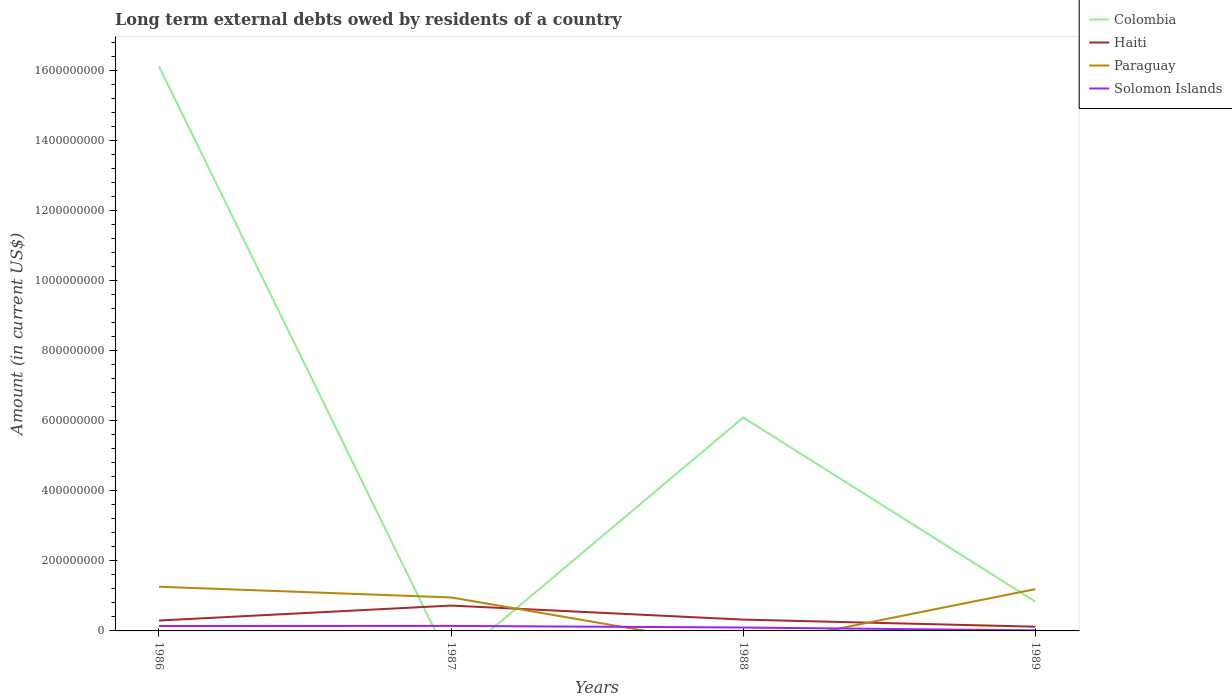How many different coloured lines are there?
Your answer should be compact. 4. Is the number of lines equal to the number of legend labels?
Offer a terse response. No. What is the total amount of long-term external debts owed by residents in Haiti in the graph?
Your answer should be compact. 1.77e+07. What is the difference between the highest and the second highest amount of long-term external debts owed by residents in Colombia?
Ensure brevity in your answer.  1.61e+09. How many lines are there?
Give a very brief answer. 4. What is the difference between two consecutive major ticks on the Y-axis?
Your response must be concise. 2.00e+08. Does the graph contain any zero values?
Make the answer very short. Yes. Does the graph contain grids?
Ensure brevity in your answer.  No. How many legend labels are there?
Your answer should be compact. 4. How are the legend labels stacked?
Make the answer very short. Vertical. What is the title of the graph?
Offer a terse response. Long term external debts owed by residents of a country. Does "Iceland" appear as one of the legend labels in the graph?
Provide a succinct answer. No. What is the label or title of the X-axis?
Your answer should be compact. Years. What is the label or title of the Y-axis?
Give a very brief answer. Amount (in current US$). What is the Amount (in current US$) of Colombia in 1986?
Ensure brevity in your answer.  1.61e+09. What is the Amount (in current US$) of Haiti in 1986?
Provide a succinct answer. 2.97e+07. What is the Amount (in current US$) of Paraguay in 1986?
Offer a very short reply. 1.26e+08. What is the Amount (in current US$) of Solomon Islands in 1986?
Your answer should be very brief. 1.40e+07. What is the Amount (in current US$) in Colombia in 1987?
Offer a very short reply. 0. What is the Amount (in current US$) of Haiti in 1987?
Make the answer very short. 7.24e+07. What is the Amount (in current US$) of Paraguay in 1987?
Offer a very short reply. 9.57e+07. What is the Amount (in current US$) of Solomon Islands in 1987?
Keep it short and to the point. 1.43e+07. What is the Amount (in current US$) of Colombia in 1988?
Make the answer very short. 6.09e+08. What is the Amount (in current US$) of Haiti in 1988?
Provide a succinct answer. 3.23e+07. What is the Amount (in current US$) in Solomon Islands in 1988?
Offer a very short reply. 9.66e+06. What is the Amount (in current US$) of Colombia in 1989?
Your response must be concise. 8.36e+07. What is the Amount (in current US$) in Haiti in 1989?
Provide a short and direct response. 1.21e+07. What is the Amount (in current US$) of Paraguay in 1989?
Offer a very short reply. 1.19e+08. What is the Amount (in current US$) in Solomon Islands in 1989?
Offer a terse response. 1.51e+06. Across all years, what is the maximum Amount (in current US$) in Colombia?
Offer a terse response. 1.61e+09. Across all years, what is the maximum Amount (in current US$) of Haiti?
Provide a succinct answer. 7.24e+07. Across all years, what is the maximum Amount (in current US$) of Paraguay?
Ensure brevity in your answer.  1.26e+08. Across all years, what is the maximum Amount (in current US$) of Solomon Islands?
Keep it short and to the point. 1.43e+07. Across all years, what is the minimum Amount (in current US$) of Colombia?
Keep it short and to the point. 0. Across all years, what is the minimum Amount (in current US$) in Haiti?
Your answer should be compact. 1.21e+07. Across all years, what is the minimum Amount (in current US$) in Paraguay?
Your response must be concise. 0. Across all years, what is the minimum Amount (in current US$) of Solomon Islands?
Make the answer very short. 1.51e+06. What is the total Amount (in current US$) in Colombia in the graph?
Ensure brevity in your answer.  2.30e+09. What is the total Amount (in current US$) in Haiti in the graph?
Your response must be concise. 1.46e+08. What is the total Amount (in current US$) of Paraguay in the graph?
Keep it short and to the point. 3.41e+08. What is the total Amount (in current US$) in Solomon Islands in the graph?
Your answer should be compact. 3.95e+07. What is the difference between the Amount (in current US$) of Haiti in 1986 and that in 1987?
Your answer should be compact. -4.27e+07. What is the difference between the Amount (in current US$) of Paraguay in 1986 and that in 1987?
Offer a very short reply. 3.05e+07. What is the difference between the Amount (in current US$) of Solomon Islands in 1986 and that in 1987?
Provide a succinct answer. -3.19e+05. What is the difference between the Amount (in current US$) in Colombia in 1986 and that in 1988?
Provide a short and direct response. 1.00e+09. What is the difference between the Amount (in current US$) in Haiti in 1986 and that in 1988?
Ensure brevity in your answer.  -2.56e+06. What is the difference between the Amount (in current US$) in Solomon Islands in 1986 and that in 1988?
Provide a succinct answer. 4.36e+06. What is the difference between the Amount (in current US$) of Colombia in 1986 and that in 1989?
Make the answer very short. 1.53e+09. What is the difference between the Amount (in current US$) in Haiti in 1986 and that in 1989?
Provide a short and direct response. 1.77e+07. What is the difference between the Amount (in current US$) in Paraguay in 1986 and that in 1989?
Offer a terse response. 6.81e+06. What is the difference between the Amount (in current US$) in Solomon Islands in 1986 and that in 1989?
Your answer should be compact. 1.25e+07. What is the difference between the Amount (in current US$) of Haiti in 1987 and that in 1988?
Your answer should be compact. 4.01e+07. What is the difference between the Amount (in current US$) of Solomon Islands in 1987 and that in 1988?
Your answer should be very brief. 4.68e+06. What is the difference between the Amount (in current US$) of Haiti in 1987 and that in 1989?
Your response must be concise. 6.03e+07. What is the difference between the Amount (in current US$) of Paraguay in 1987 and that in 1989?
Offer a terse response. -2.36e+07. What is the difference between the Amount (in current US$) in Solomon Islands in 1987 and that in 1989?
Keep it short and to the point. 1.28e+07. What is the difference between the Amount (in current US$) in Colombia in 1988 and that in 1989?
Provide a succinct answer. 5.26e+08. What is the difference between the Amount (in current US$) of Haiti in 1988 and that in 1989?
Ensure brevity in your answer.  2.02e+07. What is the difference between the Amount (in current US$) of Solomon Islands in 1988 and that in 1989?
Give a very brief answer. 8.15e+06. What is the difference between the Amount (in current US$) in Colombia in 1986 and the Amount (in current US$) in Haiti in 1987?
Provide a short and direct response. 1.54e+09. What is the difference between the Amount (in current US$) of Colombia in 1986 and the Amount (in current US$) of Paraguay in 1987?
Your response must be concise. 1.52e+09. What is the difference between the Amount (in current US$) of Colombia in 1986 and the Amount (in current US$) of Solomon Islands in 1987?
Give a very brief answer. 1.60e+09. What is the difference between the Amount (in current US$) of Haiti in 1986 and the Amount (in current US$) of Paraguay in 1987?
Your answer should be compact. -6.59e+07. What is the difference between the Amount (in current US$) of Haiti in 1986 and the Amount (in current US$) of Solomon Islands in 1987?
Make the answer very short. 1.54e+07. What is the difference between the Amount (in current US$) in Paraguay in 1986 and the Amount (in current US$) in Solomon Islands in 1987?
Your answer should be compact. 1.12e+08. What is the difference between the Amount (in current US$) in Colombia in 1986 and the Amount (in current US$) in Haiti in 1988?
Provide a short and direct response. 1.58e+09. What is the difference between the Amount (in current US$) in Colombia in 1986 and the Amount (in current US$) in Solomon Islands in 1988?
Provide a short and direct response. 1.60e+09. What is the difference between the Amount (in current US$) of Haiti in 1986 and the Amount (in current US$) of Solomon Islands in 1988?
Your answer should be compact. 2.01e+07. What is the difference between the Amount (in current US$) in Paraguay in 1986 and the Amount (in current US$) in Solomon Islands in 1988?
Your answer should be compact. 1.16e+08. What is the difference between the Amount (in current US$) in Colombia in 1986 and the Amount (in current US$) in Haiti in 1989?
Keep it short and to the point. 1.60e+09. What is the difference between the Amount (in current US$) in Colombia in 1986 and the Amount (in current US$) in Paraguay in 1989?
Ensure brevity in your answer.  1.49e+09. What is the difference between the Amount (in current US$) in Colombia in 1986 and the Amount (in current US$) in Solomon Islands in 1989?
Keep it short and to the point. 1.61e+09. What is the difference between the Amount (in current US$) in Haiti in 1986 and the Amount (in current US$) in Paraguay in 1989?
Keep it short and to the point. -8.96e+07. What is the difference between the Amount (in current US$) in Haiti in 1986 and the Amount (in current US$) in Solomon Islands in 1989?
Give a very brief answer. 2.82e+07. What is the difference between the Amount (in current US$) of Paraguay in 1986 and the Amount (in current US$) of Solomon Islands in 1989?
Offer a very short reply. 1.25e+08. What is the difference between the Amount (in current US$) of Haiti in 1987 and the Amount (in current US$) of Solomon Islands in 1988?
Offer a very short reply. 6.27e+07. What is the difference between the Amount (in current US$) of Paraguay in 1987 and the Amount (in current US$) of Solomon Islands in 1988?
Provide a succinct answer. 8.60e+07. What is the difference between the Amount (in current US$) in Haiti in 1987 and the Amount (in current US$) in Paraguay in 1989?
Make the answer very short. -4.69e+07. What is the difference between the Amount (in current US$) in Haiti in 1987 and the Amount (in current US$) in Solomon Islands in 1989?
Your response must be concise. 7.09e+07. What is the difference between the Amount (in current US$) of Paraguay in 1987 and the Amount (in current US$) of Solomon Islands in 1989?
Offer a very short reply. 9.41e+07. What is the difference between the Amount (in current US$) of Colombia in 1988 and the Amount (in current US$) of Haiti in 1989?
Your answer should be compact. 5.97e+08. What is the difference between the Amount (in current US$) in Colombia in 1988 and the Amount (in current US$) in Paraguay in 1989?
Make the answer very short. 4.90e+08. What is the difference between the Amount (in current US$) of Colombia in 1988 and the Amount (in current US$) of Solomon Islands in 1989?
Ensure brevity in your answer.  6.08e+08. What is the difference between the Amount (in current US$) in Haiti in 1988 and the Amount (in current US$) in Paraguay in 1989?
Make the answer very short. -8.70e+07. What is the difference between the Amount (in current US$) in Haiti in 1988 and the Amount (in current US$) in Solomon Islands in 1989?
Offer a very short reply. 3.08e+07. What is the average Amount (in current US$) of Colombia per year?
Your answer should be compact. 5.76e+08. What is the average Amount (in current US$) of Haiti per year?
Give a very brief answer. 3.66e+07. What is the average Amount (in current US$) in Paraguay per year?
Keep it short and to the point. 8.53e+07. What is the average Amount (in current US$) of Solomon Islands per year?
Your answer should be very brief. 9.88e+06. In the year 1986, what is the difference between the Amount (in current US$) of Colombia and Amount (in current US$) of Haiti?
Provide a succinct answer. 1.58e+09. In the year 1986, what is the difference between the Amount (in current US$) in Colombia and Amount (in current US$) in Paraguay?
Keep it short and to the point. 1.49e+09. In the year 1986, what is the difference between the Amount (in current US$) in Colombia and Amount (in current US$) in Solomon Islands?
Offer a terse response. 1.60e+09. In the year 1986, what is the difference between the Amount (in current US$) of Haiti and Amount (in current US$) of Paraguay?
Keep it short and to the point. -9.64e+07. In the year 1986, what is the difference between the Amount (in current US$) of Haiti and Amount (in current US$) of Solomon Islands?
Provide a short and direct response. 1.57e+07. In the year 1986, what is the difference between the Amount (in current US$) of Paraguay and Amount (in current US$) of Solomon Islands?
Keep it short and to the point. 1.12e+08. In the year 1987, what is the difference between the Amount (in current US$) in Haiti and Amount (in current US$) in Paraguay?
Keep it short and to the point. -2.33e+07. In the year 1987, what is the difference between the Amount (in current US$) of Haiti and Amount (in current US$) of Solomon Islands?
Your answer should be compact. 5.80e+07. In the year 1987, what is the difference between the Amount (in current US$) of Paraguay and Amount (in current US$) of Solomon Islands?
Provide a succinct answer. 8.13e+07. In the year 1988, what is the difference between the Amount (in current US$) in Colombia and Amount (in current US$) in Haiti?
Your answer should be very brief. 5.77e+08. In the year 1988, what is the difference between the Amount (in current US$) in Colombia and Amount (in current US$) in Solomon Islands?
Your response must be concise. 6.00e+08. In the year 1988, what is the difference between the Amount (in current US$) of Haiti and Amount (in current US$) of Solomon Islands?
Provide a short and direct response. 2.26e+07. In the year 1989, what is the difference between the Amount (in current US$) of Colombia and Amount (in current US$) of Haiti?
Your answer should be compact. 7.15e+07. In the year 1989, what is the difference between the Amount (in current US$) of Colombia and Amount (in current US$) of Paraguay?
Your response must be concise. -3.57e+07. In the year 1989, what is the difference between the Amount (in current US$) of Colombia and Amount (in current US$) of Solomon Islands?
Your answer should be compact. 8.21e+07. In the year 1989, what is the difference between the Amount (in current US$) of Haiti and Amount (in current US$) of Paraguay?
Keep it short and to the point. -1.07e+08. In the year 1989, what is the difference between the Amount (in current US$) in Haiti and Amount (in current US$) in Solomon Islands?
Ensure brevity in your answer.  1.05e+07. In the year 1989, what is the difference between the Amount (in current US$) in Paraguay and Amount (in current US$) in Solomon Islands?
Offer a terse response. 1.18e+08. What is the ratio of the Amount (in current US$) of Haiti in 1986 to that in 1987?
Offer a very short reply. 0.41. What is the ratio of the Amount (in current US$) of Paraguay in 1986 to that in 1987?
Provide a short and direct response. 1.32. What is the ratio of the Amount (in current US$) of Solomon Islands in 1986 to that in 1987?
Offer a terse response. 0.98. What is the ratio of the Amount (in current US$) of Colombia in 1986 to that in 1988?
Your response must be concise. 2.64. What is the ratio of the Amount (in current US$) in Haiti in 1986 to that in 1988?
Make the answer very short. 0.92. What is the ratio of the Amount (in current US$) in Solomon Islands in 1986 to that in 1988?
Your response must be concise. 1.45. What is the ratio of the Amount (in current US$) in Colombia in 1986 to that in 1989?
Offer a very short reply. 19.28. What is the ratio of the Amount (in current US$) of Haiti in 1986 to that in 1989?
Offer a terse response. 2.47. What is the ratio of the Amount (in current US$) in Paraguay in 1986 to that in 1989?
Provide a succinct answer. 1.06. What is the ratio of the Amount (in current US$) in Solomon Islands in 1986 to that in 1989?
Your answer should be compact. 9.26. What is the ratio of the Amount (in current US$) of Haiti in 1987 to that in 1988?
Ensure brevity in your answer.  2.24. What is the ratio of the Amount (in current US$) of Solomon Islands in 1987 to that in 1988?
Your response must be concise. 1.48. What is the ratio of the Amount (in current US$) of Haiti in 1987 to that in 1989?
Offer a terse response. 6. What is the ratio of the Amount (in current US$) of Paraguay in 1987 to that in 1989?
Your answer should be very brief. 0.8. What is the ratio of the Amount (in current US$) of Solomon Islands in 1987 to that in 1989?
Your answer should be compact. 9.47. What is the ratio of the Amount (in current US$) of Colombia in 1988 to that in 1989?
Offer a terse response. 7.29. What is the ratio of the Amount (in current US$) in Haiti in 1988 to that in 1989?
Provide a short and direct response. 2.68. What is the ratio of the Amount (in current US$) of Solomon Islands in 1988 to that in 1989?
Provide a short and direct response. 6.38. What is the difference between the highest and the second highest Amount (in current US$) in Colombia?
Offer a terse response. 1.00e+09. What is the difference between the highest and the second highest Amount (in current US$) in Haiti?
Make the answer very short. 4.01e+07. What is the difference between the highest and the second highest Amount (in current US$) of Paraguay?
Your answer should be very brief. 6.81e+06. What is the difference between the highest and the second highest Amount (in current US$) of Solomon Islands?
Provide a short and direct response. 3.19e+05. What is the difference between the highest and the lowest Amount (in current US$) in Colombia?
Your response must be concise. 1.61e+09. What is the difference between the highest and the lowest Amount (in current US$) of Haiti?
Provide a short and direct response. 6.03e+07. What is the difference between the highest and the lowest Amount (in current US$) of Paraguay?
Offer a terse response. 1.26e+08. What is the difference between the highest and the lowest Amount (in current US$) in Solomon Islands?
Provide a succinct answer. 1.28e+07. 